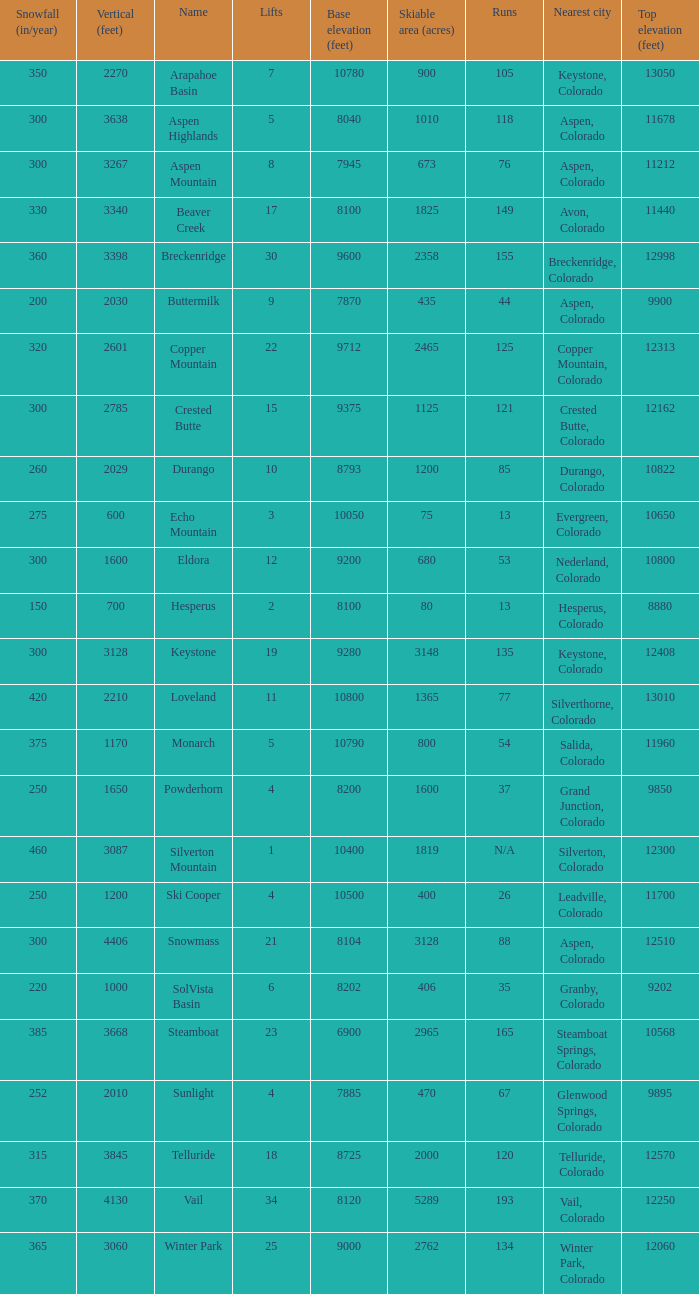Could you parse the entire table as a dict? {'header': ['Snowfall (in/year)', 'Vertical (feet)', 'Name', 'Lifts', 'Base elevation (feet)', 'Skiable area (acres)', 'Runs', 'Nearest city', 'Top elevation (feet)'], 'rows': [['350', '2270', 'Arapahoe Basin', '7', '10780', '900', '105', 'Keystone, Colorado', '13050'], ['300', '3638', 'Aspen Highlands', '5', '8040', '1010', '118', 'Aspen, Colorado', '11678'], ['300', '3267', 'Aspen Mountain', '8', '7945', '673', '76', 'Aspen, Colorado', '11212'], ['330', '3340', 'Beaver Creek', '17', '8100', '1825', '149', 'Avon, Colorado', '11440'], ['360', '3398', 'Breckenridge', '30', '9600', '2358', '155', 'Breckenridge, Colorado', '12998'], ['200', '2030', 'Buttermilk', '9', '7870', '435', '44', 'Aspen, Colorado', '9900'], ['320', '2601', 'Copper Mountain', '22', '9712', '2465', '125', 'Copper Mountain, Colorado', '12313'], ['300', '2785', 'Crested Butte', '15', '9375', '1125', '121', 'Crested Butte, Colorado', '12162'], ['260', '2029', 'Durango', '10', '8793', '1200', '85', 'Durango, Colorado', '10822'], ['275', '600', 'Echo Mountain', '3', '10050', '75', '13', 'Evergreen, Colorado', '10650'], ['300', '1600', 'Eldora', '12', '9200', '680', '53', 'Nederland, Colorado', '10800'], ['150', '700', 'Hesperus', '2', '8100', '80', '13', 'Hesperus, Colorado', '8880'], ['300', '3128', 'Keystone', '19', '9280', '3148', '135', 'Keystone, Colorado', '12408'], ['420', '2210', 'Loveland', '11', '10800', '1365', '77', 'Silverthorne, Colorado', '13010'], ['375', '1170', 'Monarch', '5', '10790', '800', '54', 'Salida, Colorado', '11960'], ['250', '1650', 'Powderhorn', '4', '8200', '1600', '37', 'Grand Junction, Colorado', '9850'], ['460', '3087', 'Silverton Mountain', '1', '10400', '1819', 'N/A', 'Silverton, Colorado', '12300'], ['250', '1200', 'Ski Cooper', '4', '10500', '400', '26', 'Leadville, Colorado', '11700'], ['300', '4406', 'Snowmass', '21', '8104', '3128', '88', 'Aspen, Colorado', '12510'], ['220', '1000', 'SolVista Basin', '6', '8202', '406', '35', 'Granby, Colorado', '9202'], ['385', '3668', 'Steamboat', '23', '6900', '2965', '165', 'Steamboat Springs, Colorado', '10568'], ['252', '2010', 'Sunlight', '4', '7885', '470', '67', 'Glenwood Springs, Colorado', '9895'], ['315', '3845', 'Telluride', '18', '8725', '2000', '120', 'Telluride, Colorado', '12570'], ['370', '4130', 'Vail', '34', '8120', '5289', '193', 'Vail, Colorado', '12250'], ['365', '3060', 'Winter Park', '25', '9000', '2762', '134', 'Winter Park, Colorado', '12060']]} If the name is Steamboat, what is the top elevation? 10568.0. 